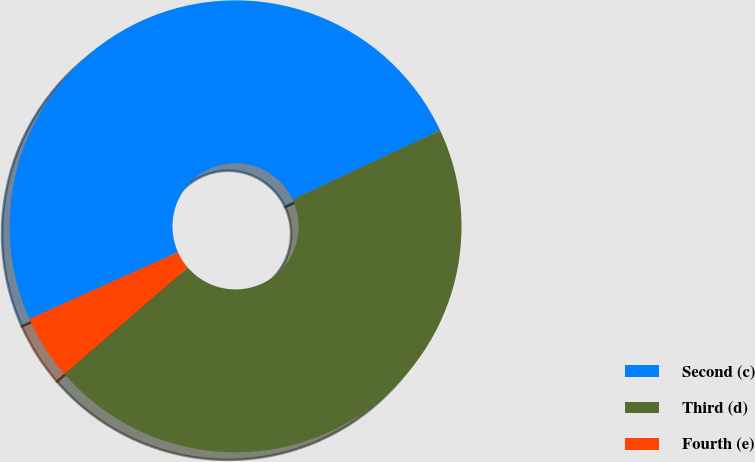<chart> <loc_0><loc_0><loc_500><loc_500><pie_chart><fcel>Second (c)<fcel>Third (d)<fcel>Fourth (e)<nl><fcel>49.74%<fcel>45.64%<fcel>4.62%<nl></chart> 